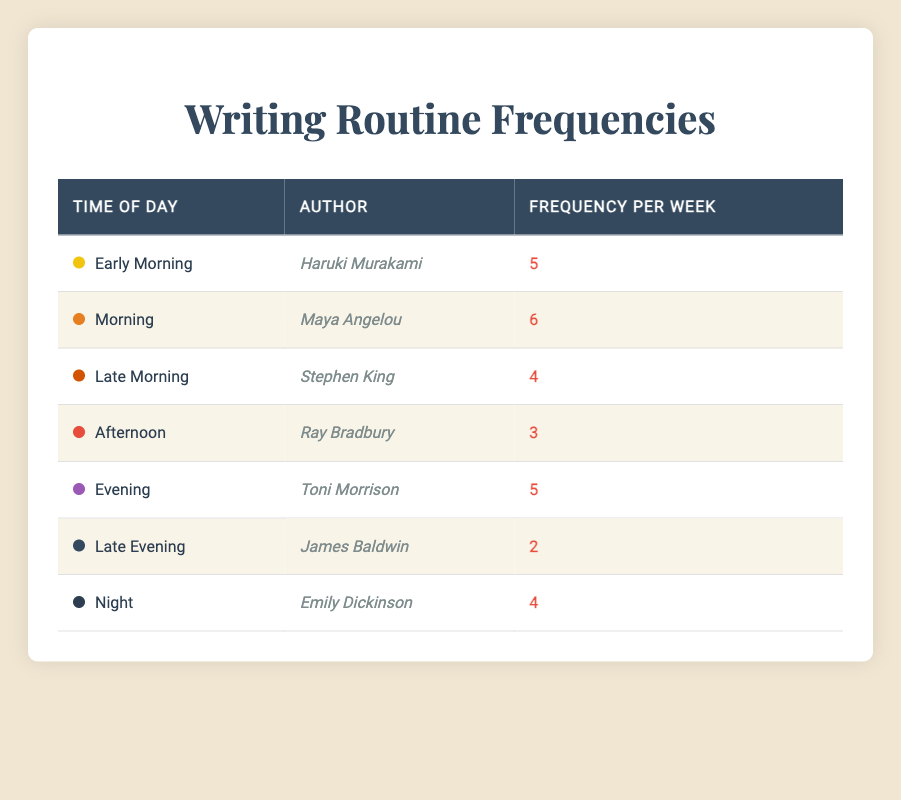What is the writing frequency of Maya Angelou? The table indicates that Maya Angelou writes in the morning with a frequency of 6 times per week.
Answer: 6 Which author writes the least frequently and what is their frequency? The author who writes the least frequently is James Baldwin, who writes 2 times per week in the late evening.
Answer: James Baldwin, 2 What is the total writing frequency of authors who write in the evening and night combined? To find the total, we add the frequencies for evening (5) and night (4). Thus, 5 + 4 = 9.
Answer: 9 Which time of the day has the highest writing frequency and who is the author that writes during that time? The highest writing frequency is in the morning with Maya Angelou at 6 times per week.
Answer: Morning, Maya Angelou Is it true that all authors write more frequently in the early part of the day compared to the late part of the day? Comparing the frequencies, Haruki Murakami (5) and Maya Angelou (6) write in the early part of the day, while in the late part, the highest is Toni Morrison (5). Since some authors write more in the late evening (James Baldwin, 2) and at night (Emily Dickinson, 4) than some in the early part, the answer is no.
Answer: No What is the average writing frequency of the authors listed in the table? To calculate the average, we sum the frequencies (5 + 6 + 4 + 3 + 5 + 2 + 4 = 29) and divide by the number of authors (7). Hence, the average is 29 / 7 ≈ 4.14.
Answer: 4.14 How many authors write more than 4 times per week? The authors who write more than 4 times per week are Maya Angelou (6), Haruki Murakami (5), and Toni Morrison (5). This gives us a total of 3 authors.
Answer: 3 What is the difference in frequency between the most and least frequent authors? The most frequent author is Maya Angelou at 6 times, and the least frequent is James Baldwin at 2 times. The difference is 6 - 2 = 4.
Answer: 4 